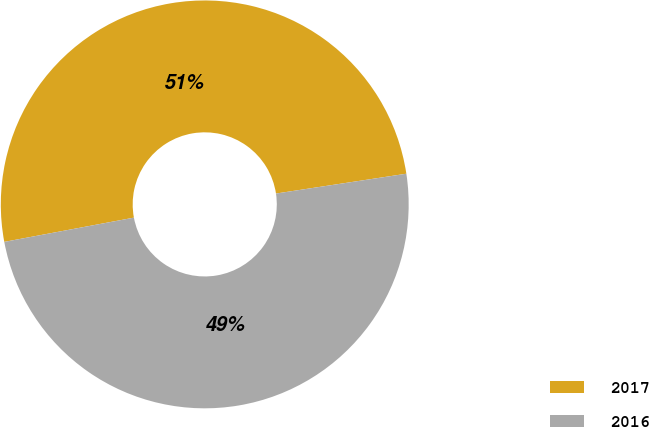Convert chart. <chart><loc_0><loc_0><loc_500><loc_500><pie_chart><fcel>2017<fcel>2016<nl><fcel>50.54%<fcel>49.46%<nl></chart> 